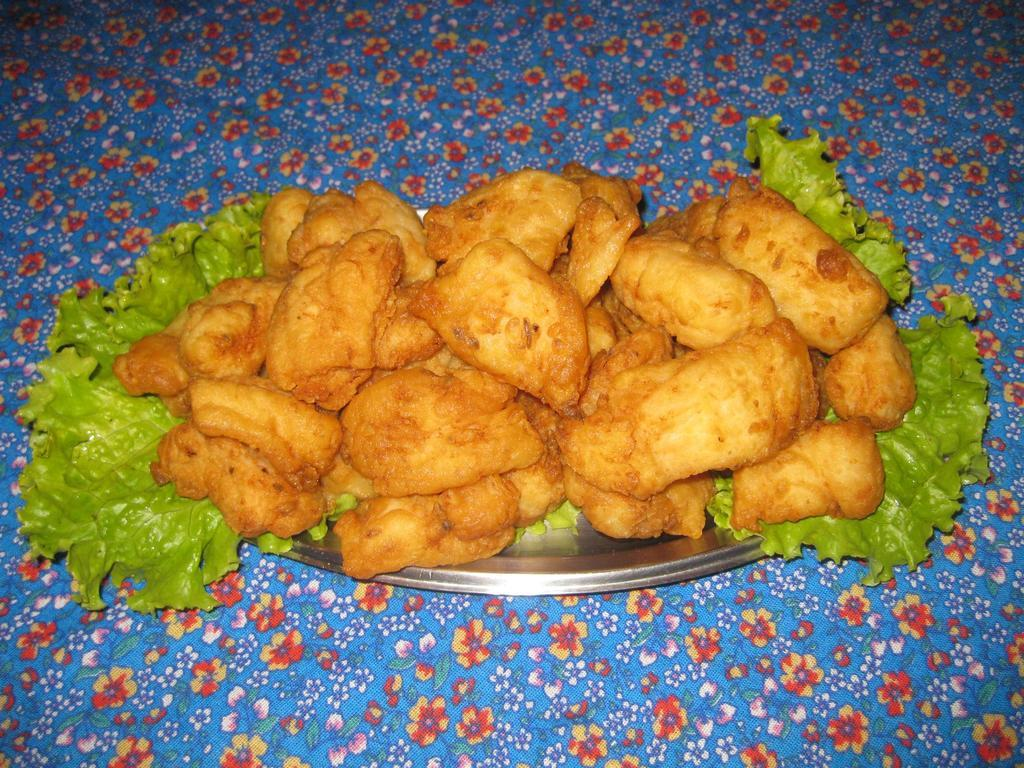What is the main subject in the center of the image? There are snacks in the center of the image. What is placed on the snacks? There are leaves on the plate with the snacks. What is located at the bottom of the image? There is a table at the bottom of the image. What type of thrill can be seen in the image? There is no thrill present in the image; it features snacks with leaves on a table. 